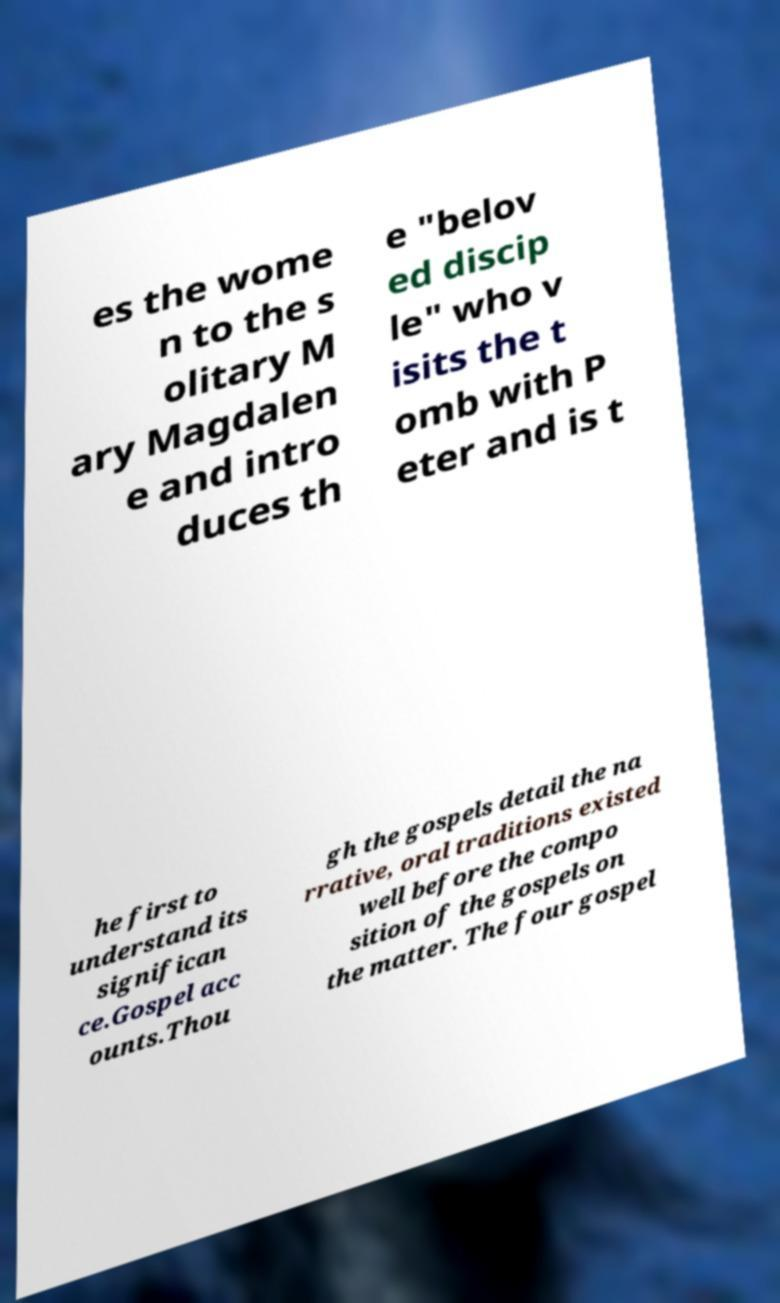Please read and relay the text visible in this image. What does it say? es the wome n to the s olitary M ary Magdalen e and intro duces th e "belov ed discip le" who v isits the t omb with P eter and is t he first to understand its significan ce.Gospel acc ounts.Thou gh the gospels detail the na rrative, oral traditions existed well before the compo sition of the gospels on the matter. The four gospel 